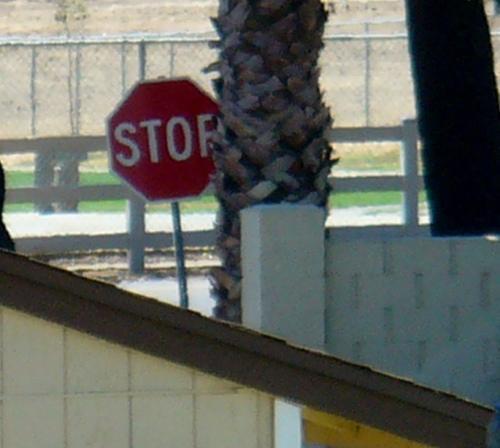How many hot dog buns are present in this photo?
Give a very brief answer. 0. 